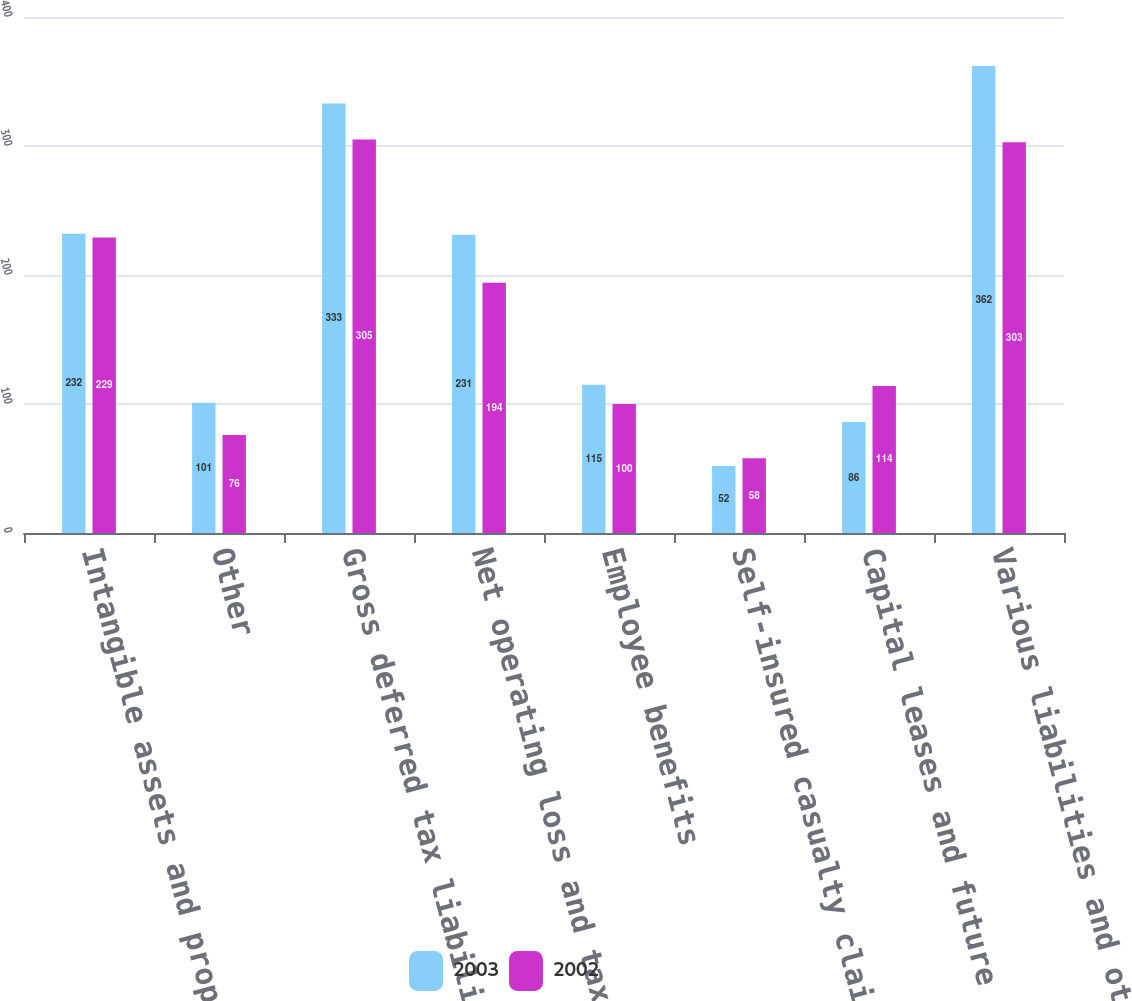Convert chart to OTSL. <chart><loc_0><loc_0><loc_500><loc_500><stacked_bar_chart><ecel><fcel>Intangible assets and property<fcel>Other<fcel>Gross deferred tax liabilities<fcel>Net operating loss and tax<fcel>Employee benefits<fcel>Self-insured casualty claims<fcel>Capital leases and future rent<fcel>Various liabilities and other<nl><fcel>2003<fcel>232<fcel>101<fcel>333<fcel>231<fcel>115<fcel>52<fcel>86<fcel>362<nl><fcel>2002<fcel>229<fcel>76<fcel>305<fcel>194<fcel>100<fcel>58<fcel>114<fcel>303<nl></chart> 